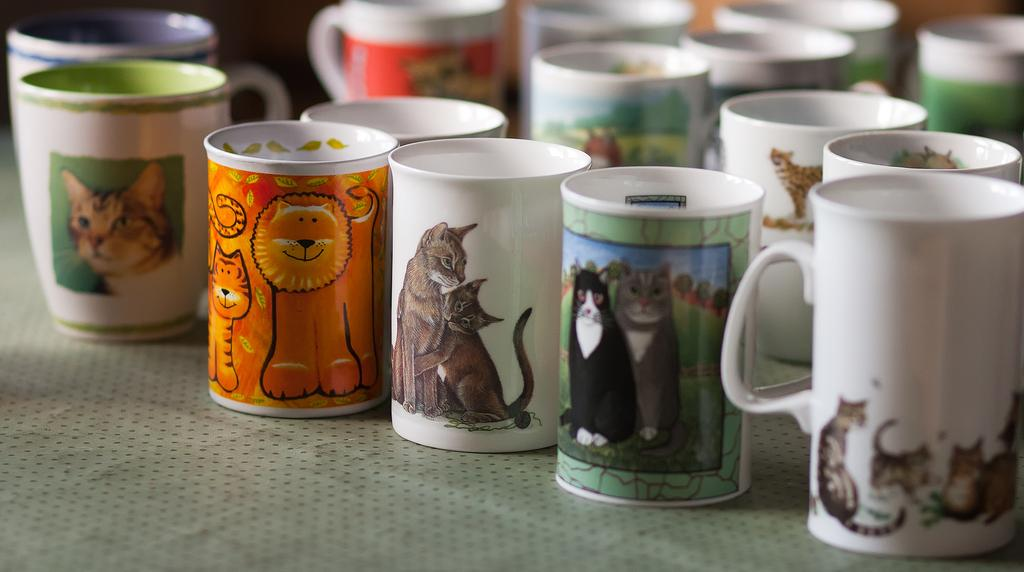What objects are present in the image in a group? There is a group of cups in the image. What design or art can be seen on the cups? The cups have some art on them. What surface can be seen at the bottom of the image? There appears to be a table at the bottom of the image. How many snakes are slithering on the table in the image? There are no snakes present in the image; the table is empty except for the group of cups. 